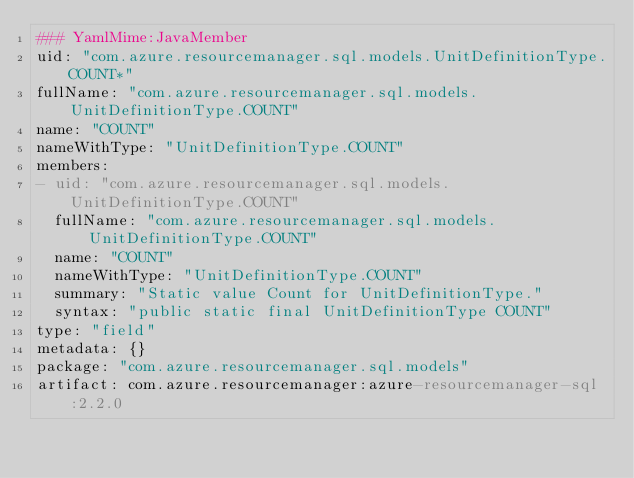Convert code to text. <code><loc_0><loc_0><loc_500><loc_500><_YAML_>### YamlMime:JavaMember
uid: "com.azure.resourcemanager.sql.models.UnitDefinitionType.COUNT*"
fullName: "com.azure.resourcemanager.sql.models.UnitDefinitionType.COUNT"
name: "COUNT"
nameWithType: "UnitDefinitionType.COUNT"
members:
- uid: "com.azure.resourcemanager.sql.models.UnitDefinitionType.COUNT"
  fullName: "com.azure.resourcemanager.sql.models.UnitDefinitionType.COUNT"
  name: "COUNT"
  nameWithType: "UnitDefinitionType.COUNT"
  summary: "Static value Count for UnitDefinitionType."
  syntax: "public static final UnitDefinitionType COUNT"
type: "field"
metadata: {}
package: "com.azure.resourcemanager.sql.models"
artifact: com.azure.resourcemanager:azure-resourcemanager-sql:2.2.0
</code> 